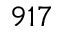Convert formula to latex. <formula><loc_0><loc_0><loc_500><loc_500>9 1 7</formula> 